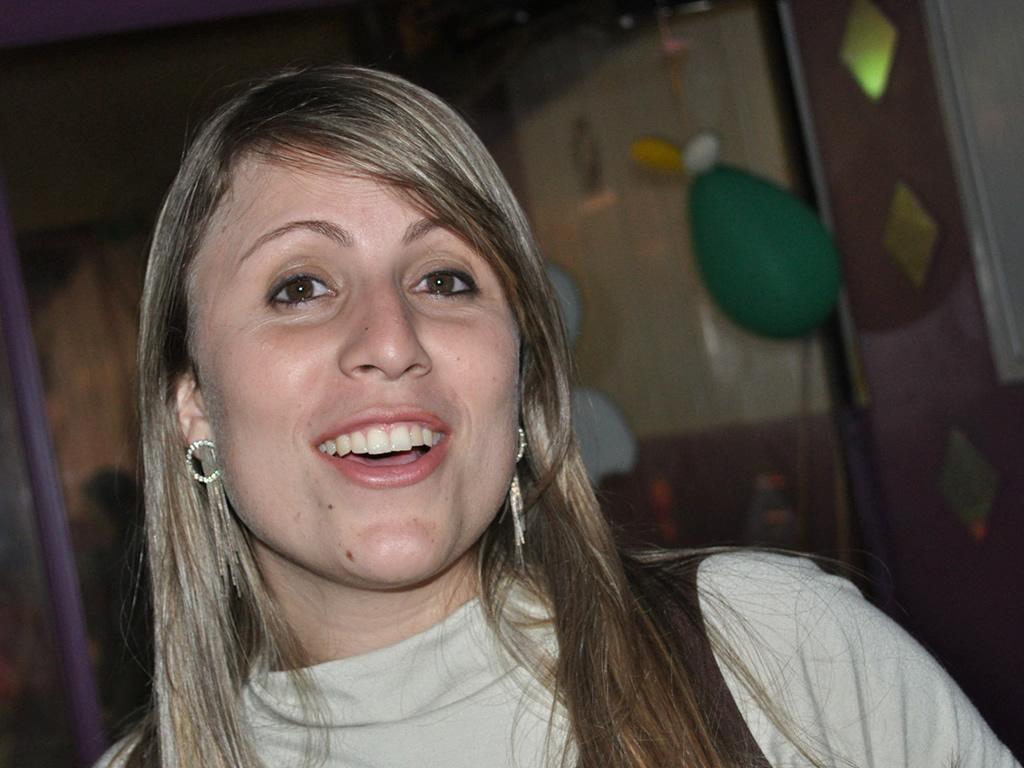Please provide a concise description of this image. In this picture we can see a woman wearing earrings and smiling. We can see a pole and colorful objects in the background. 